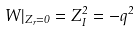Convert formula to latex. <formula><loc_0><loc_0><loc_500><loc_500>W | _ { Z _ { r } = 0 } = Z _ { I } ^ { 2 } = - q ^ { 2 }</formula> 